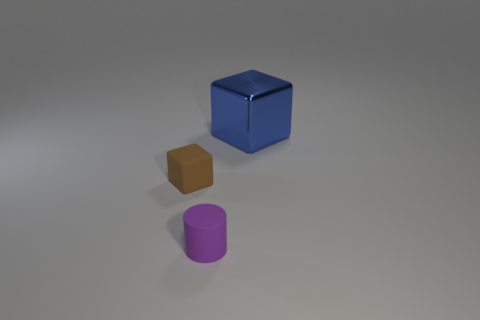Add 3 green cubes. How many objects exist? 6 Subtract all blocks. How many objects are left? 1 Subtract 0 brown cylinders. How many objects are left? 3 Subtract all small purple rubber objects. Subtract all cyan shiny cubes. How many objects are left? 2 Add 3 purple things. How many purple things are left? 4 Add 1 small purple matte blocks. How many small purple matte blocks exist? 1 